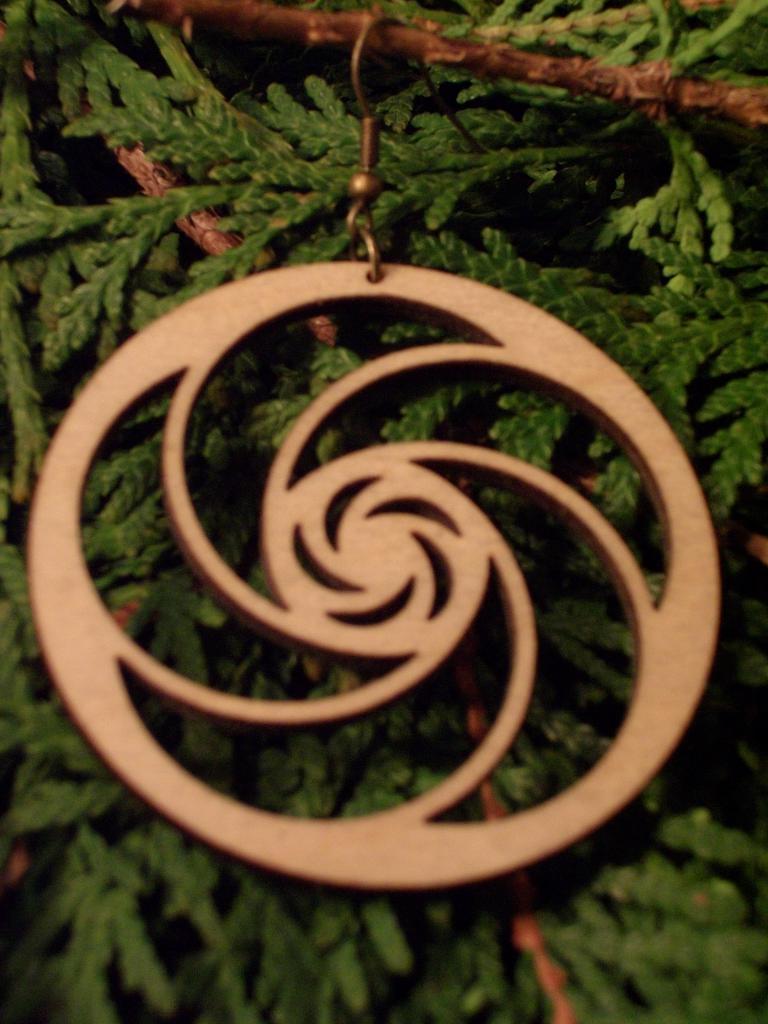In one or two sentences, can you explain what this image depicts? In this image, we can see some leaves. There is a decor in the middle of the image. 